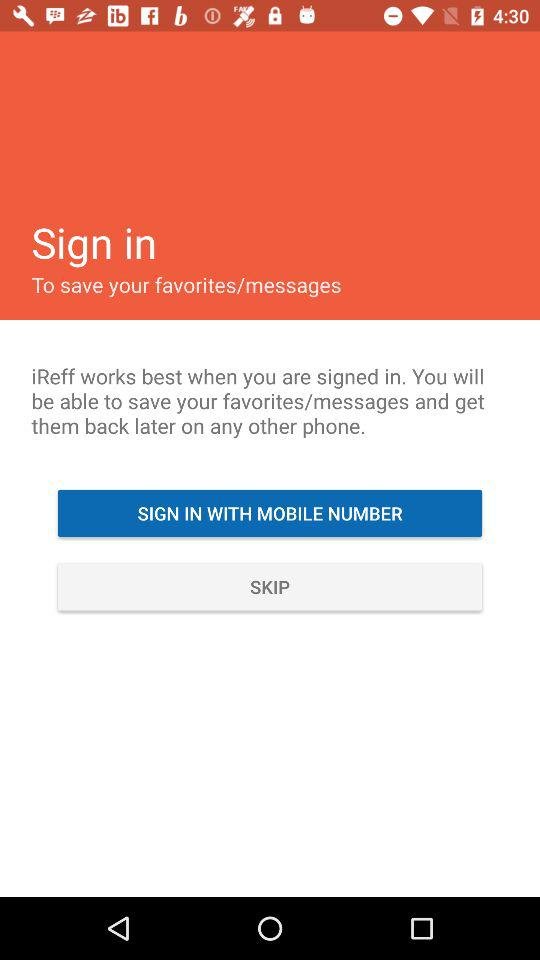How can the user sign in? The user can sign in with a mobile number. 